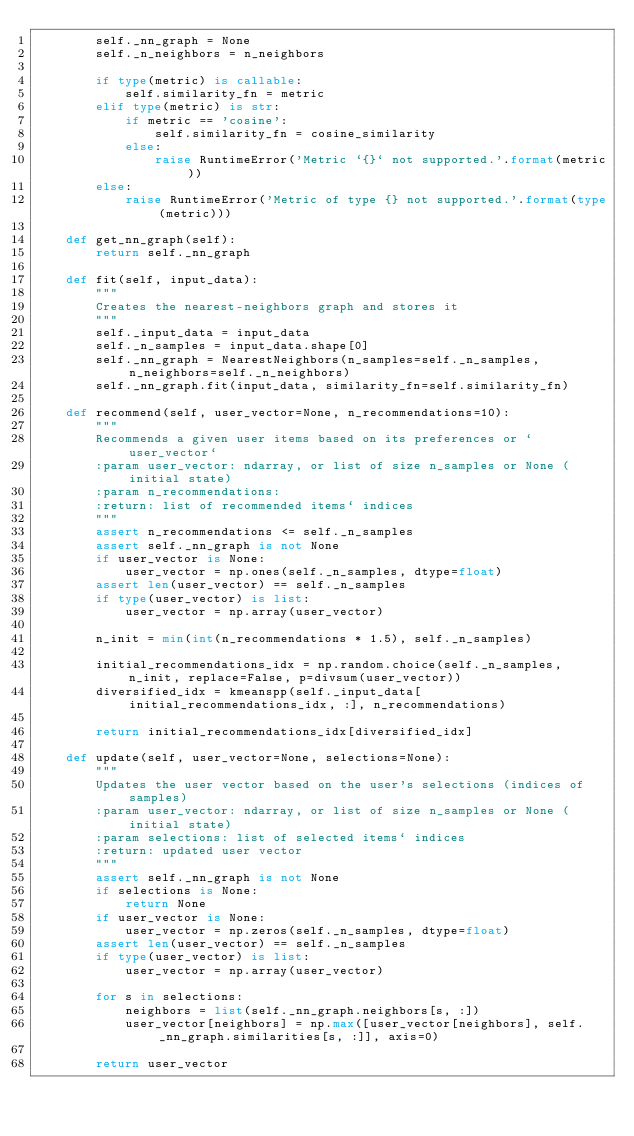Convert code to text. <code><loc_0><loc_0><loc_500><loc_500><_Python_>        self._nn_graph = None
        self._n_neighbors = n_neighbors

        if type(metric) is callable:
            self.similarity_fn = metric
        elif type(metric) is str:
            if metric == 'cosine':
                self.similarity_fn = cosine_similarity
            else:
                raise RuntimeError('Metric `{}` not supported.'.format(metric))
        else:
            raise RuntimeError('Metric of type {} not supported.'.format(type(metric)))

    def get_nn_graph(self):
        return self._nn_graph

    def fit(self, input_data):
        """
        Creates the nearest-neighbors graph and stores it
        """
        self._input_data = input_data
        self._n_samples = input_data.shape[0]
        self._nn_graph = NearestNeighbors(n_samples=self._n_samples, n_neighbors=self._n_neighbors)
        self._nn_graph.fit(input_data, similarity_fn=self.similarity_fn)

    def recommend(self, user_vector=None, n_recommendations=10):
        """
        Recommends a given user items based on its preferences or `user_vector`
        :param user_vector: ndarray, or list of size n_samples or None (initial state)
        :param n_recommendations:
        :return: list of recommended items` indices
        """
        assert n_recommendations <= self._n_samples
        assert self._nn_graph is not None
        if user_vector is None:
            user_vector = np.ones(self._n_samples, dtype=float)
        assert len(user_vector) == self._n_samples
        if type(user_vector) is list:
            user_vector = np.array(user_vector)

        n_init = min(int(n_recommendations * 1.5), self._n_samples)

        initial_recommendations_idx = np.random.choice(self._n_samples, n_init, replace=False, p=divsum(user_vector))
        diversified_idx = kmeanspp(self._input_data[initial_recommendations_idx, :], n_recommendations)

        return initial_recommendations_idx[diversified_idx]

    def update(self, user_vector=None, selections=None):
        """
        Updates the user vector based on the user's selections (indices of samples)
        :param user_vector: ndarray, or list of size n_samples or None (initial state)
        :param selections: list of selected items` indices
        :return: updated user vector
        """
        assert self._nn_graph is not None
        if selections is None:
            return None
        if user_vector is None:
            user_vector = np.zeros(self._n_samples, dtype=float)
        assert len(user_vector) == self._n_samples
        if type(user_vector) is list:
            user_vector = np.array(user_vector)

        for s in selections:
            neighbors = list(self._nn_graph.neighbors[s, :])
            user_vector[neighbors] = np.max([user_vector[neighbors], self._nn_graph.similarities[s, :]], axis=0)

        return user_vector
</code> 